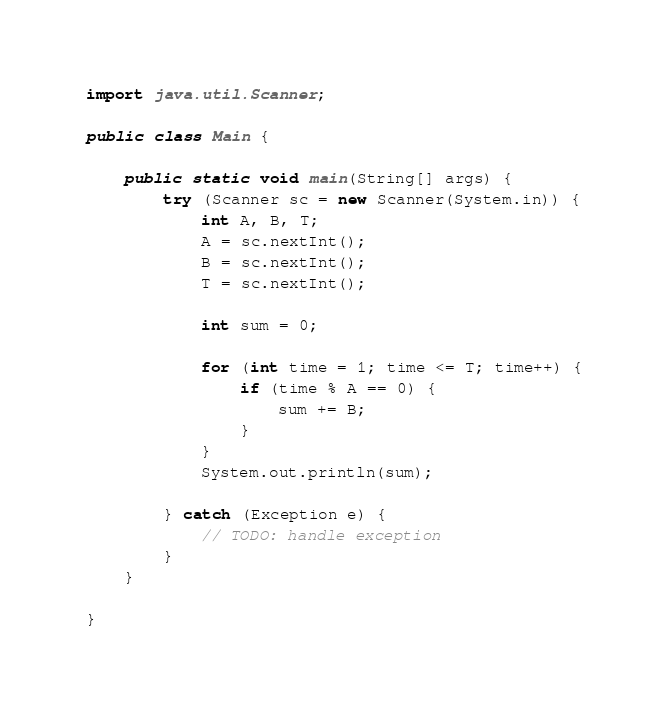<code> <loc_0><loc_0><loc_500><loc_500><_Java_>import java.util.Scanner;

public class Main {

	public static void main(String[] args) {
		try (Scanner sc = new Scanner(System.in)) {
			int A, B, T;
			A = sc.nextInt();
			B = sc.nextInt();
			T = sc.nextInt();
			
			int sum = 0;
			
			for (int time = 1; time <= T; time++) {
				if (time % A == 0) {
					sum += B;
				}
			}
			System.out.println(sum);
			
		} catch (Exception e) {
			// TODO: handle exception
		}
	}

}</code> 